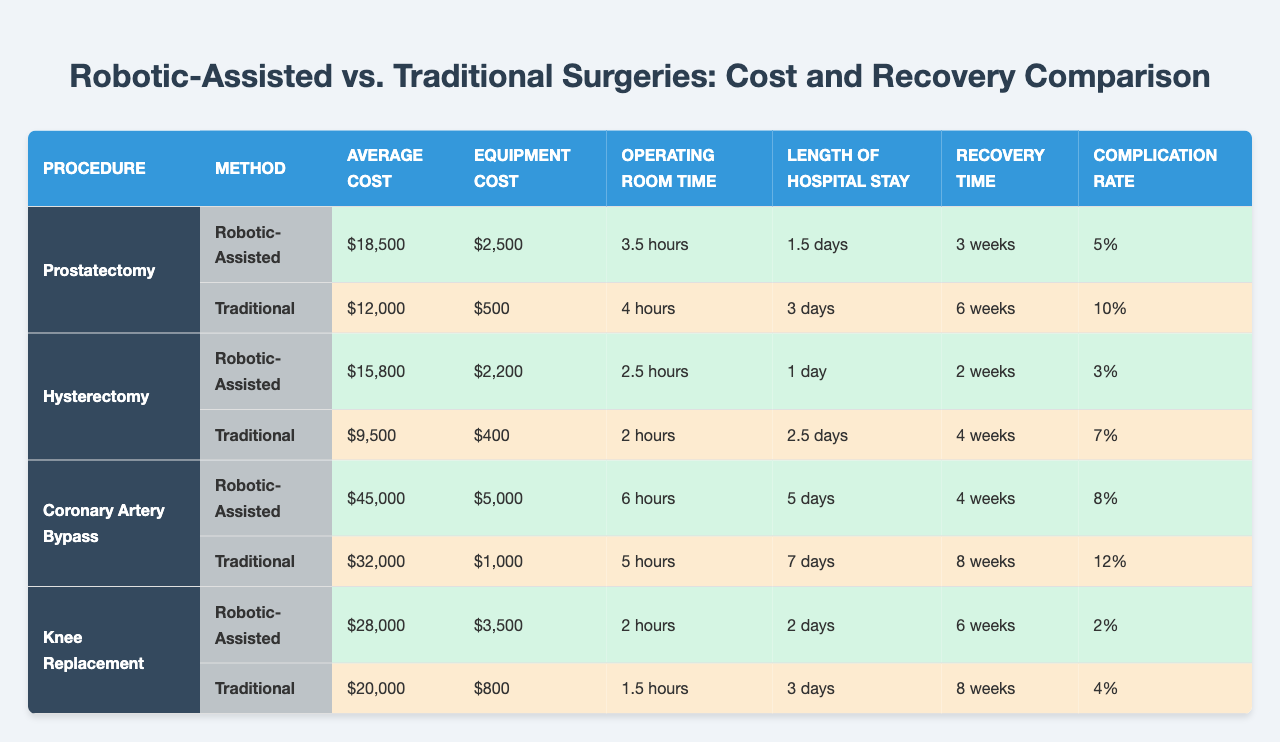What is the average cost of robotic-assisted prostatectomy? From the table, the average cost of robotic-assisted prostatectomy is displayed as "$18,500".
Answer: $18,500 What is the equipment cost for traditional hysterectomy? The equipment cost for traditional hysterectomy, according to the table, is "$400".
Answer: $400 Which surgery has the longest recovery time, robotic-assisted or traditional? For robotic-assisted surgeries, the longest recovery time is for the coronary artery bypass at "4 weeks". For traditional, it is for the same procedure at "8 weeks". Thus, traditional has the longest recovery time.
Answer: Traditional surgery has the longest recovery time What is the difference in average cost between robotic-assisted and traditional knee replacement surgeries? The average cost of robotic-assisted knee replacement is "$28,000" and traditional is "$20,000". The difference is $28,000 - $20,000 = $8,000.
Answer: $8,000 True or False: The complication rate for robotic-assisted prostatectomy is higher than for traditional prostatectomy. The complication rate for robotic-assisted prostatectomy is "5%", while for traditional it is "10%", which is higher. Thus, the statement is false.
Answer: False What is the total average cost of robotic-assisted surgeries listed in the table? The robotic-assisted surgeries' average costs are $18,500 (prostatectomy) + $15,800 (hysterectomy) + $45,000 (coronary artery bypass) + $28,000 (knee replacement). The sum is $18,500 + $15,800 + $45,000 + $28,000 = $107,300.
Answer: $107,300 Which type of surgery has the lowest complication rate, robotic-assisted or traditional? Comparing complication rates, robotic-assisted surgeries show complication rates of 5%, 3%, 8%, and 2% while traditional surgeries show rates of 10%, 7%, 12%, and 4%. The lowest is robotic-assisted knee replacement at "2%", making it lower than the traditional rates.
Answer: Robotic-assisted surgery has the lowest complication rate What is the average recovery time for robotic-assisted surgeries based on the table? The robotic-assisted recovery times are 3 weeks (prostatectomy), 2 weeks (hysterectomy), 4 weeks (coronary artery bypass), and 6 weeks (knee replacement). The average is calculated as (3 + 2 + 4 + 6) / 4 = 3.75 weeks.
Answer: 3.75 weeks Which procedure has the shortest length of hospital stay for robotic-assisted methods? The length of hospital stay for robotic-assisted procedures includes: 1.5 days (prostatectomy), 1 day (hysterectomy), 5 days (coronary artery bypass), and 2 days (knee replacement). The shortest is 1 day for hysterectomy.
Answer: Hysterectomy has the shortest length of hospital stay 